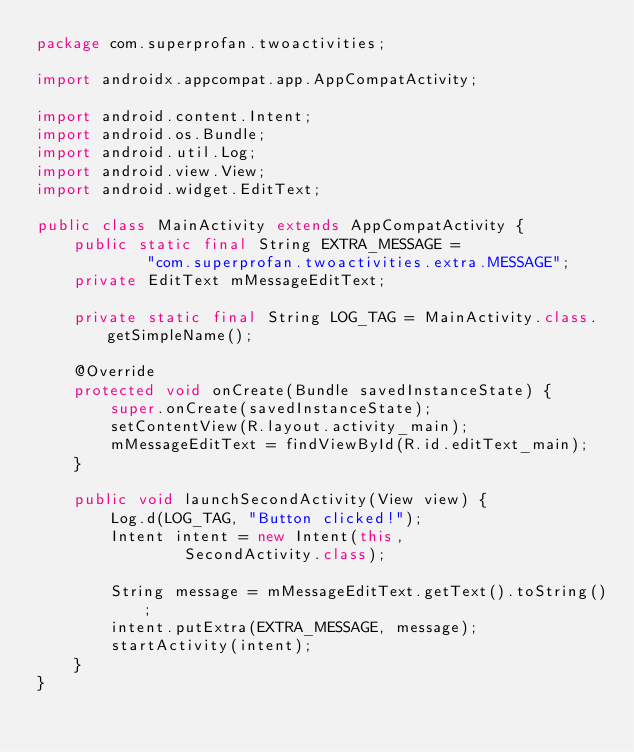<code> <loc_0><loc_0><loc_500><loc_500><_Java_>package com.superprofan.twoactivities;

import androidx.appcompat.app.AppCompatActivity;

import android.content.Intent;
import android.os.Bundle;
import android.util.Log;
import android.view.View;
import android.widget.EditText;

public class MainActivity extends AppCompatActivity {
    public static final String EXTRA_MESSAGE =
            "com.superprofan.twoactivities.extra.MESSAGE";
    private EditText mMessageEditText;

    private static final String LOG_TAG = MainActivity.class.getSimpleName();

    @Override
    protected void onCreate(Bundle savedInstanceState) {
        super.onCreate(savedInstanceState);
        setContentView(R.layout.activity_main);
        mMessageEditText = findViewById(R.id.editText_main);
    }

    public void launchSecondActivity(View view) {
        Log.d(LOG_TAG, "Button clicked!");
        Intent intent = new Intent(this,
                SecondActivity.class);

        String message = mMessageEditText.getText().toString();
        intent.putExtra(EXTRA_MESSAGE, message);
        startActivity(intent);
    }
}</code> 